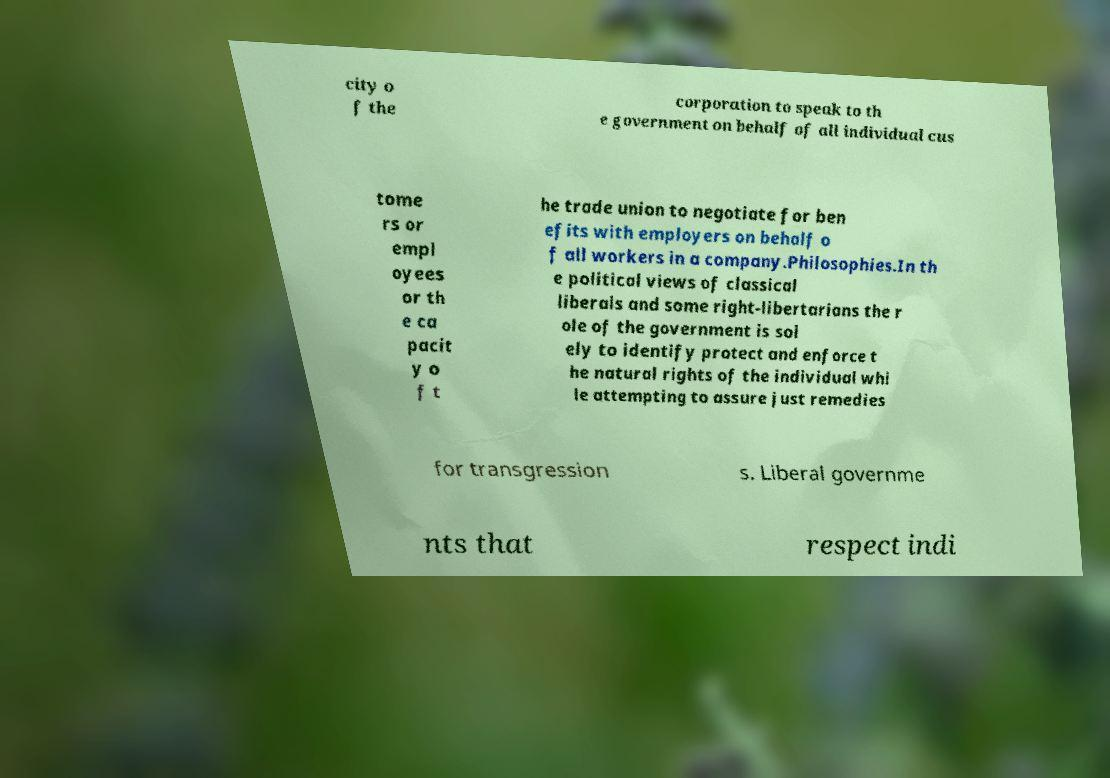What messages or text are displayed in this image? I need them in a readable, typed format. city o f the corporation to speak to th e government on behalf of all individual cus tome rs or empl oyees or th e ca pacit y o f t he trade union to negotiate for ben efits with employers on behalf o f all workers in a company.Philosophies.In th e political views of classical liberals and some right-libertarians the r ole of the government is sol ely to identify protect and enforce t he natural rights of the individual whi le attempting to assure just remedies for transgression s. Liberal governme nts that respect indi 